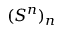Convert formula to latex. <formula><loc_0><loc_0><loc_500><loc_500>( S ^ { n } ) _ { n }</formula> 